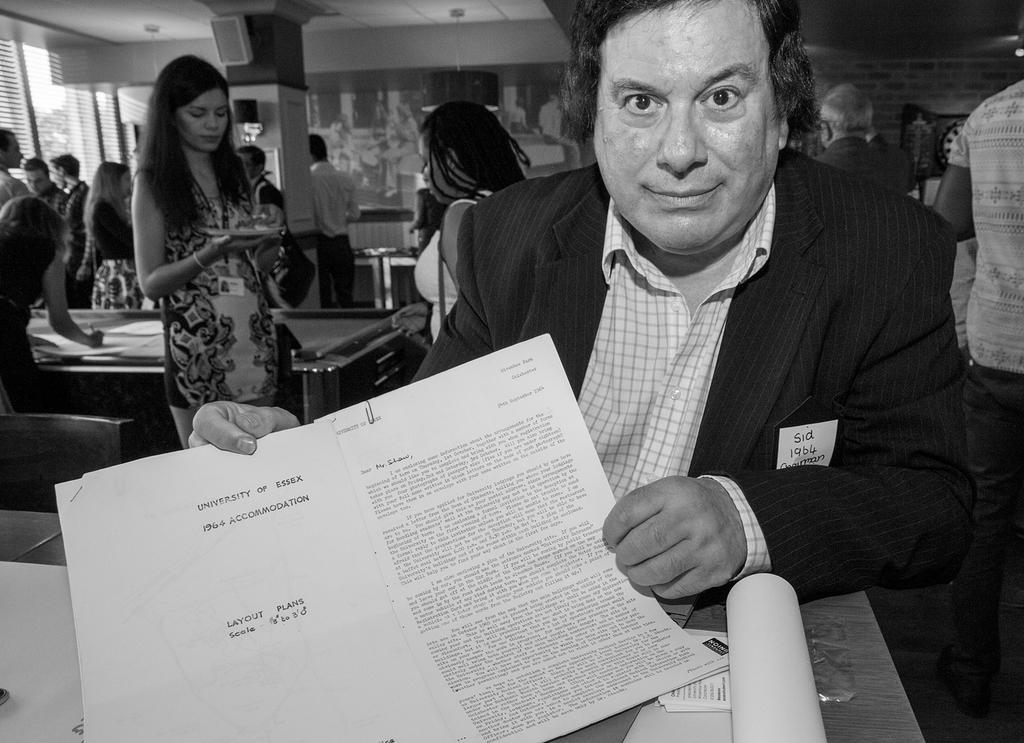Who is the main subject in the image? There is a man in the image. What is the man holding in the image? The man is holding papers in the image. Can you describe the papers in more detail? There is writing on the papers. What can be seen in the background of the image? There are people in the background of the image. How is the image presented in terms of color? The image is in black and white. What type of sign is the man holding in the image? There is no sign present in the image; the man is holding papers with writing on them. What effect does the poison have on the people in the image? There is no mention of poison or any negative effects on the people in the image. 